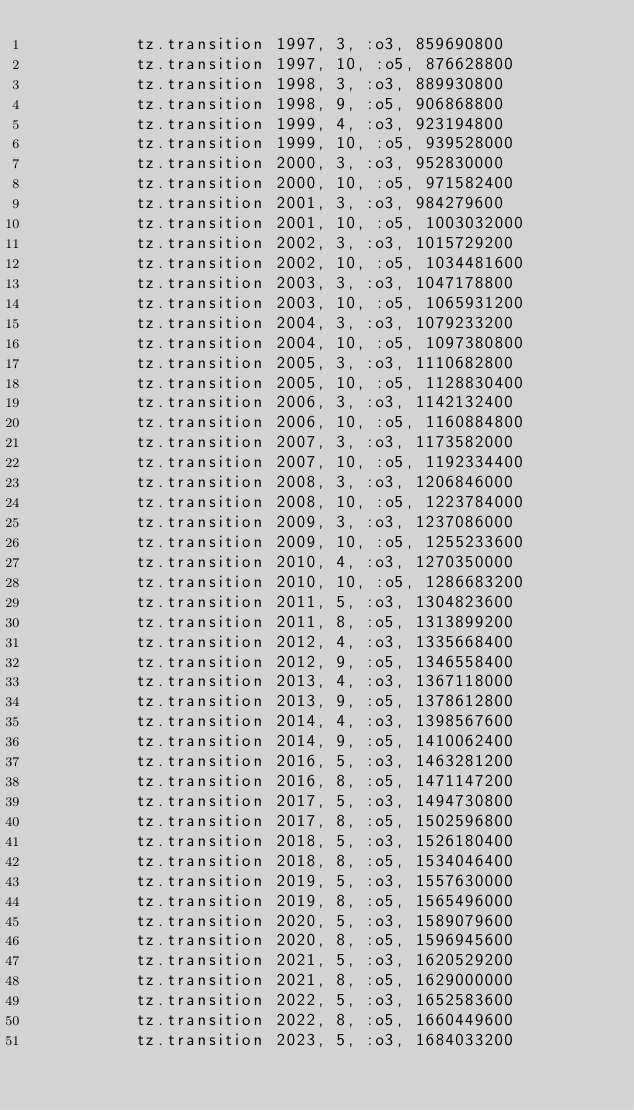<code> <loc_0><loc_0><loc_500><loc_500><_Ruby_>          tz.transition 1997, 3, :o3, 859690800
          tz.transition 1997, 10, :o5, 876628800
          tz.transition 1998, 3, :o3, 889930800
          tz.transition 1998, 9, :o5, 906868800
          tz.transition 1999, 4, :o3, 923194800
          tz.transition 1999, 10, :o5, 939528000
          tz.transition 2000, 3, :o3, 952830000
          tz.transition 2000, 10, :o5, 971582400
          tz.transition 2001, 3, :o3, 984279600
          tz.transition 2001, 10, :o5, 1003032000
          tz.transition 2002, 3, :o3, 1015729200
          tz.transition 2002, 10, :o5, 1034481600
          tz.transition 2003, 3, :o3, 1047178800
          tz.transition 2003, 10, :o5, 1065931200
          tz.transition 2004, 3, :o3, 1079233200
          tz.transition 2004, 10, :o5, 1097380800
          tz.transition 2005, 3, :o3, 1110682800
          tz.transition 2005, 10, :o5, 1128830400
          tz.transition 2006, 3, :o3, 1142132400
          tz.transition 2006, 10, :o5, 1160884800
          tz.transition 2007, 3, :o3, 1173582000
          tz.transition 2007, 10, :o5, 1192334400
          tz.transition 2008, 3, :o3, 1206846000
          tz.transition 2008, 10, :o5, 1223784000
          tz.transition 2009, 3, :o3, 1237086000
          tz.transition 2009, 10, :o5, 1255233600
          tz.transition 2010, 4, :o3, 1270350000
          tz.transition 2010, 10, :o5, 1286683200
          tz.transition 2011, 5, :o3, 1304823600
          tz.transition 2011, 8, :o5, 1313899200
          tz.transition 2012, 4, :o3, 1335668400
          tz.transition 2012, 9, :o5, 1346558400
          tz.transition 2013, 4, :o3, 1367118000
          tz.transition 2013, 9, :o5, 1378612800
          tz.transition 2014, 4, :o3, 1398567600
          tz.transition 2014, 9, :o5, 1410062400
          tz.transition 2016, 5, :o3, 1463281200
          tz.transition 2016, 8, :o5, 1471147200
          tz.transition 2017, 5, :o3, 1494730800
          tz.transition 2017, 8, :o5, 1502596800
          tz.transition 2018, 5, :o3, 1526180400
          tz.transition 2018, 8, :o5, 1534046400
          tz.transition 2019, 5, :o3, 1557630000
          tz.transition 2019, 8, :o5, 1565496000
          tz.transition 2020, 5, :o3, 1589079600
          tz.transition 2020, 8, :o5, 1596945600
          tz.transition 2021, 5, :o3, 1620529200
          tz.transition 2021, 8, :o5, 1629000000
          tz.transition 2022, 5, :o3, 1652583600
          tz.transition 2022, 8, :o5, 1660449600
          tz.transition 2023, 5, :o3, 1684033200</code> 